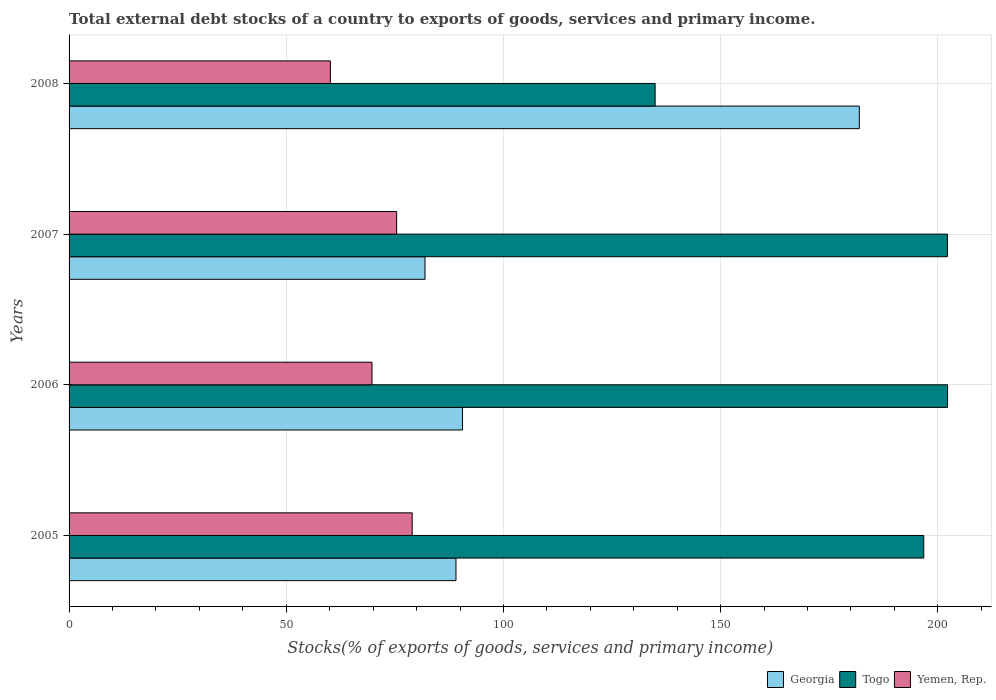How many different coloured bars are there?
Offer a terse response. 3. Are the number of bars per tick equal to the number of legend labels?
Make the answer very short. Yes. How many bars are there on the 2nd tick from the top?
Your answer should be very brief. 3. In how many cases, is the number of bars for a given year not equal to the number of legend labels?
Provide a succinct answer. 0. What is the total debt stocks in Togo in 2007?
Offer a very short reply. 202.22. Across all years, what is the maximum total debt stocks in Georgia?
Your answer should be very brief. 181.93. Across all years, what is the minimum total debt stocks in Togo?
Offer a very short reply. 134.92. In which year was the total debt stocks in Togo maximum?
Make the answer very short. 2006. In which year was the total debt stocks in Togo minimum?
Make the answer very short. 2008. What is the total total debt stocks in Togo in the graph?
Make the answer very short. 736.15. What is the difference between the total debt stocks in Georgia in 2006 and that in 2007?
Ensure brevity in your answer.  8.63. What is the difference between the total debt stocks in Togo in 2008 and the total debt stocks in Yemen, Rep. in 2007?
Give a very brief answer. 59.51. What is the average total debt stocks in Togo per year?
Make the answer very short. 184.04. In the year 2006, what is the difference between the total debt stocks in Georgia and total debt stocks in Yemen, Rep.?
Your answer should be compact. 20.84. What is the ratio of the total debt stocks in Yemen, Rep. in 2006 to that in 2007?
Your response must be concise. 0.92. What is the difference between the highest and the second highest total debt stocks in Yemen, Rep.?
Provide a succinct answer. 3.58. What is the difference between the highest and the lowest total debt stocks in Yemen, Rep.?
Keep it short and to the point. 18.83. What does the 2nd bar from the top in 2007 represents?
Provide a short and direct response. Togo. What does the 1st bar from the bottom in 2007 represents?
Your response must be concise. Georgia. Are all the bars in the graph horizontal?
Ensure brevity in your answer.  Yes. How many years are there in the graph?
Your answer should be very brief. 4. What is the difference between two consecutive major ticks on the X-axis?
Your answer should be compact. 50. Does the graph contain any zero values?
Your answer should be compact. No. Where does the legend appear in the graph?
Provide a succinct answer. Bottom right. How many legend labels are there?
Provide a short and direct response. 3. How are the legend labels stacked?
Keep it short and to the point. Horizontal. What is the title of the graph?
Give a very brief answer. Total external debt stocks of a country to exports of goods, services and primary income. What is the label or title of the X-axis?
Make the answer very short. Stocks(% of exports of goods, services and primary income). What is the Stocks(% of exports of goods, services and primary income) of Georgia in 2005?
Give a very brief answer. 89.07. What is the Stocks(% of exports of goods, services and primary income) in Togo in 2005?
Your answer should be very brief. 196.76. What is the Stocks(% of exports of goods, services and primary income) in Yemen, Rep. in 2005?
Provide a short and direct response. 78.99. What is the Stocks(% of exports of goods, services and primary income) in Georgia in 2006?
Offer a terse response. 90.58. What is the Stocks(% of exports of goods, services and primary income) in Togo in 2006?
Provide a succinct answer. 202.25. What is the Stocks(% of exports of goods, services and primary income) in Yemen, Rep. in 2006?
Provide a succinct answer. 69.74. What is the Stocks(% of exports of goods, services and primary income) of Georgia in 2007?
Your answer should be very brief. 81.94. What is the Stocks(% of exports of goods, services and primary income) of Togo in 2007?
Provide a succinct answer. 202.22. What is the Stocks(% of exports of goods, services and primary income) in Yemen, Rep. in 2007?
Provide a succinct answer. 75.41. What is the Stocks(% of exports of goods, services and primary income) of Georgia in 2008?
Offer a terse response. 181.93. What is the Stocks(% of exports of goods, services and primary income) of Togo in 2008?
Keep it short and to the point. 134.92. What is the Stocks(% of exports of goods, services and primary income) of Yemen, Rep. in 2008?
Offer a terse response. 60.16. Across all years, what is the maximum Stocks(% of exports of goods, services and primary income) in Georgia?
Your response must be concise. 181.93. Across all years, what is the maximum Stocks(% of exports of goods, services and primary income) of Togo?
Give a very brief answer. 202.25. Across all years, what is the maximum Stocks(% of exports of goods, services and primary income) of Yemen, Rep.?
Provide a succinct answer. 78.99. Across all years, what is the minimum Stocks(% of exports of goods, services and primary income) in Georgia?
Provide a succinct answer. 81.94. Across all years, what is the minimum Stocks(% of exports of goods, services and primary income) in Togo?
Keep it short and to the point. 134.92. Across all years, what is the minimum Stocks(% of exports of goods, services and primary income) in Yemen, Rep.?
Ensure brevity in your answer.  60.16. What is the total Stocks(% of exports of goods, services and primary income) in Georgia in the graph?
Make the answer very short. 443.52. What is the total Stocks(% of exports of goods, services and primary income) in Togo in the graph?
Give a very brief answer. 736.15. What is the total Stocks(% of exports of goods, services and primary income) in Yemen, Rep. in the graph?
Give a very brief answer. 284.3. What is the difference between the Stocks(% of exports of goods, services and primary income) in Georgia in 2005 and that in 2006?
Provide a short and direct response. -1.5. What is the difference between the Stocks(% of exports of goods, services and primary income) of Togo in 2005 and that in 2006?
Keep it short and to the point. -5.48. What is the difference between the Stocks(% of exports of goods, services and primary income) of Yemen, Rep. in 2005 and that in 2006?
Your answer should be very brief. 9.25. What is the difference between the Stocks(% of exports of goods, services and primary income) of Georgia in 2005 and that in 2007?
Your response must be concise. 7.13. What is the difference between the Stocks(% of exports of goods, services and primary income) in Togo in 2005 and that in 2007?
Your answer should be compact. -5.45. What is the difference between the Stocks(% of exports of goods, services and primary income) in Yemen, Rep. in 2005 and that in 2007?
Your answer should be compact. 3.58. What is the difference between the Stocks(% of exports of goods, services and primary income) of Georgia in 2005 and that in 2008?
Offer a terse response. -92.85. What is the difference between the Stocks(% of exports of goods, services and primary income) of Togo in 2005 and that in 2008?
Offer a very short reply. 61.84. What is the difference between the Stocks(% of exports of goods, services and primary income) of Yemen, Rep. in 2005 and that in 2008?
Provide a short and direct response. 18.83. What is the difference between the Stocks(% of exports of goods, services and primary income) in Georgia in 2006 and that in 2007?
Provide a succinct answer. 8.63. What is the difference between the Stocks(% of exports of goods, services and primary income) of Togo in 2006 and that in 2007?
Provide a short and direct response. 0.03. What is the difference between the Stocks(% of exports of goods, services and primary income) of Yemen, Rep. in 2006 and that in 2007?
Ensure brevity in your answer.  -5.67. What is the difference between the Stocks(% of exports of goods, services and primary income) of Georgia in 2006 and that in 2008?
Offer a very short reply. -91.35. What is the difference between the Stocks(% of exports of goods, services and primary income) in Togo in 2006 and that in 2008?
Give a very brief answer. 67.32. What is the difference between the Stocks(% of exports of goods, services and primary income) in Yemen, Rep. in 2006 and that in 2008?
Offer a terse response. 9.58. What is the difference between the Stocks(% of exports of goods, services and primary income) in Georgia in 2007 and that in 2008?
Ensure brevity in your answer.  -99.99. What is the difference between the Stocks(% of exports of goods, services and primary income) of Togo in 2007 and that in 2008?
Offer a very short reply. 67.3. What is the difference between the Stocks(% of exports of goods, services and primary income) in Yemen, Rep. in 2007 and that in 2008?
Make the answer very short. 15.26. What is the difference between the Stocks(% of exports of goods, services and primary income) of Georgia in 2005 and the Stocks(% of exports of goods, services and primary income) of Togo in 2006?
Ensure brevity in your answer.  -113.17. What is the difference between the Stocks(% of exports of goods, services and primary income) of Georgia in 2005 and the Stocks(% of exports of goods, services and primary income) of Yemen, Rep. in 2006?
Provide a short and direct response. 19.33. What is the difference between the Stocks(% of exports of goods, services and primary income) in Togo in 2005 and the Stocks(% of exports of goods, services and primary income) in Yemen, Rep. in 2006?
Give a very brief answer. 127.02. What is the difference between the Stocks(% of exports of goods, services and primary income) of Georgia in 2005 and the Stocks(% of exports of goods, services and primary income) of Togo in 2007?
Give a very brief answer. -113.14. What is the difference between the Stocks(% of exports of goods, services and primary income) of Georgia in 2005 and the Stocks(% of exports of goods, services and primary income) of Yemen, Rep. in 2007?
Provide a succinct answer. 13.66. What is the difference between the Stocks(% of exports of goods, services and primary income) of Togo in 2005 and the Stocks(% of exports of goods, services and primary income) of Yemen, Rep. in 2007?
Provide a succinct answer. 121.35. What is the difference between the Stocks(% of exports of goods, services and primary income) of Georgia in 2005 and the Stocks(% of exports of goods, services and primary income) of Togo in 2008?
Your answer should be very brief. -45.85. What is the difference between the Stocks(% of exports of goods, services and primary income) in Georgia in 2005 and the Stocks(% of exports of goods, services and primary income) in Yemen, Rep. in 2008?
Make the answer very short. 28.92. What is the difference between the Stocks(% of exports of goods, services and primary income) in Togo in 2005 and the Stocks(% of exports of goods, services and primary income) in Yemen, Rep. in 2008?
Provide a short and direct response. 136.61. What is the difference between the Stocks(% of exports of goods, services and primary income) of Georgia in 2006 and the Stocks(% of exports of goods, services and primary income) of Togo in 2007?
Keep it short and to the point. -111.64. What is the difference between the Stocks(% of exports of goods, services and primary income) in Georgia in 2006 and the Stocks(% of exports of goods, services and primary income) in Yemen, Rep. in 2007?
Provide a succinct answer. 15.16. What is the difference between the Stocks(% of exports of goods, services and primary income) of Togo in 2006 and the Stocks(% of exports of goods, services and primary income) of Yemen, Rep. in 2007?
Your response must be concise. 126.83. What is the difference between the Stocks(% of exports of goods, services and primary income) in Georgia in 2006 and the Stocks(% of exports of goods, services and primary income) in Togo in 2008?
Your answer should be compact. -44.34. What is the difference between the Stocks(% of exports of goods, services and primary income) in Georgia in 2006 and the Stocks(% of exports of goods, services and primary income) in Yemen, Rep. in 2008?
Your answer should be very brief. 30.42. What is the difference between the Stocks(% of exports of goods, services and primary income) of Togo in 2006 and the Stocks(% of exports of goods, services and primary income) of Yemen, Rep. in 2008?
Offer a terse response. 142.09. What is the difference between the Stocks(% of exports of goods, services and primary income) in Georgia in 2007 and the Stocks(% of exports of goods, services and primary income) in Togo in 2008?
Your answer should be compact. -52.98. What is the difference between the Stocks(% of exports of goods, services and primary income) in Georgia in 2007 and the Stocks(% of exports of goods, services and primary income) in Yemen, Rep. in 2008?
Provide a short and direct response. 21.79. What is the difference between the Stocks(% of exports of goods, services and primary income) in Togo in 2007 and the Stocks(% of exports of goods, services and primary income) in Yemen, Rep. in 2008?
Keep it short and to the point. 142.06. What is the average Stocks(% of exports of goods, services and primary income) in Georgia per year?
Offer a very short reply. 110.88. What is the average Stocks(% of exports of goods, services and primary income) of Togo per year?
Your response must be concise. 184.04. What is the average Stocks(% of exports of goods, services and primary income) of Yemen, Rep. per year?
Offer a very short reply. 71.08. In the year 2005, what is the difference between the Stocks(% of exports of goods, services and primary income) of Georgia and Stocks(% of exports of goods, services and primary income) of Togo?
Offer a terse response. -107.69. In the year 2005, what is the difference between the Stocks(% of exports of goods, services and primary income) in Georgia and Stocks(% of exports of goods, services and primary income) in Yemen, Rep.?
Your answer should be compact. 10.08. In the year 2005, what is the difference between the Stocks(% of exports of goods, services and primary income) of Togo and Stocks(% of exports of goods, services and primary income) of Yemen, Rep.?
Give a very brief answer. 117.77. In the year 2006, what is the difference between the Stocks(% of exports of goods, services and primary income) in Georgia and Stocks(% of exports of goods, services and primary income) in Togo?
Give a very brief answer. -111.67. In the year 2006, what is the difference between the Stocks(% of exports of goods, services and primary income) of Georgia and Stocks(% of exports of goods, services and primary income) of Yemen, Rep.?
Provide a short and direct response. 20.84. In the year 2006, what is the difference between the Stocks(% of exports of goods, services and primary income) in Togo and Stocks(% of exports of goods, services and primary income) in Yemen, Rep.?
Make the answer very short. 132.5. In the year 2007, what is the difference between the Stocks(% of exports of goods, services and primary income) in Georgia and Stocks(% of exports of goods, services and primary income) in Togo?
Give a very brief answer. -120.27. In the year 2007, what is the difference between the Stocks(% of exports of goods, services and primary income) of Georgia and Stocks(% of exports of goods, services and primary income) of Yemen, Rep.?
Your answer should be very brief. 6.53. In the year 2007, what is the difference between the Stocks(% of exports of goods, services and primary income) in Togo and Stocks(% of exports of goods, services and primary income) in Yemen, Rep.?
Your answer should be very brief. 126.8. In the year 2008, what is the difference between the Stocks(% of exports of goods, services and primary income) of Georgia and Stocks(% of exports of goods, services and primary income) of Togo?
Keep it short and to the point. 47.01. In the year 2008, what is the difference between the Stocks(% of exports of goods, services and primary income) of Georgia and Stocks(% of exports of goods, services and primary income) of Yemen, Rep.?
Give a very brief answer. 121.77. In the year 2008, what is the difference between the Stocks(% of exports of goods, services and primary income) in Togo and Stocks(% of exports of goods, services and primary income) in Yemen, Rep.?
Provide a short and direct response. 74.76. What is the ratio of the Stocks(% of exports of goods, services and primary income) of Georgia in 2005 to that in 2006?
Offer a very short reply. 0.98. What is the ratio of the Stocks(% of exports of goods, services and primary income) in Togo in 2005 to that in 2006?
Provide a succinct answer. 0.97. What is the ratio of the Stocks(% of exports of goods, services and primary income) of Yemen, Rep. in 2005 to that in 2006?
Keep it short and to the point. 1.13. What is the ratio of the Stocks(% of exports of goods, services and primary income) of Georgia in 2005 to that in 2007?
Offer a very short reply. 1.09. What is the ratio of the Stocks(% of exports of goods, services and primary income) in Yemen, Rep. in 2005 to that in 2007?
Your answer should be very brief. 1.05. What is the ratio of the Stocks(% of exports of goods, services and primary income) in Georgia in 2005 to that in 2008?
Your answer should be compact. 0.49. What is the ratio of the Stocks(% of exports of goods, services and primary income) of Togo in 2005 to that in 2008?
Your response must be concise. 1.46. What is the ratio of the Stocks(% of exports of goods, services and primary income) of Yemen, Rep. in 2005 to that in 2008?
Ensure brevity in your answer.  1.31. What is the ratio of the Stocks(% of exports of goods, services and primary income) of Georgia in 2006 to that in 2007?
Make the answer very short. 1.11. What is the ratio of the Stocks(% of exports of goods, services and primary income) in Togo in 2006 to that in 2007?
Your answer should be compact. 1. What is the ratio of the Stocks(% of exports of goods, services and primary income) in Yemen, Rep. in 2006 to that in 2007?
Your response must be concise. 0.92. What is the ratio of the Stocks(% of exports of goods, services and primary income) of Georgia in 2006 to that in 2008?
Provide a short and direct response. 0.5. What is the ratio of the Stocks(% of exports of goods, services and primary income) of Togo in 2006 to that in 2008?
Offer a terse response. 1.5. What is the ratio of the Stocks(% of exports of goods, services and primary income) in Yemen, Rep. in 2006 to that in 2008?
Give a very brief answer. 1.16. What is the ratio of the Stocks(% of exports of goods, services and primary income) of Georgia in 2007 to that in 2008?
Make the answer very short. 0.45. What is the ratio of the Stocks(% of exports of goods, services and primary income) of Togo in 2007 to that in 2008?
Provide a succinct answer. 1.5. What is the ratio of the Stocks(% of exports of goods, services and primary income) of Yemen, Rep. in 2007 to that in 2008?
Offer a terse response. 1.25. What is the difference between the highest and the second highest Stocks(% of exports of goods, services and primary income) in Georgia?
Provide a short and direct response. 91.35. What is the difference between the highest and the second highest Stocks(% of exports of goods, services and primary income) of Togo?
Ensure brevity in your answer.  0.03. What is the difference between the highest and the second highest Stocks(% of exports of goods, services and primary income) of Yemen, Rep.?
Keep it short and to the point. 3.58. What is the difference between the highest and the lowest Stocks(% of exports of goods, services and primary income) of Georgia?
Your response must be concise. 99.99. What is the difference between the highest and the lowest Stocks(% of exports of goods, services and primary income) in Togo?
Your response must be concise. 67.32. What is the difference between the highest and the lowest Stocks(% of exports of goods, services and primary income) in Yemen, Rep.?
Provide a short and direct response. 18.83. 